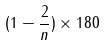Convert formula to latex. <formula><loc_0><loc_0><loc_500><loc_500>( 1 - \frac { 2 } { n } ) \times 1 8 0</formula> 